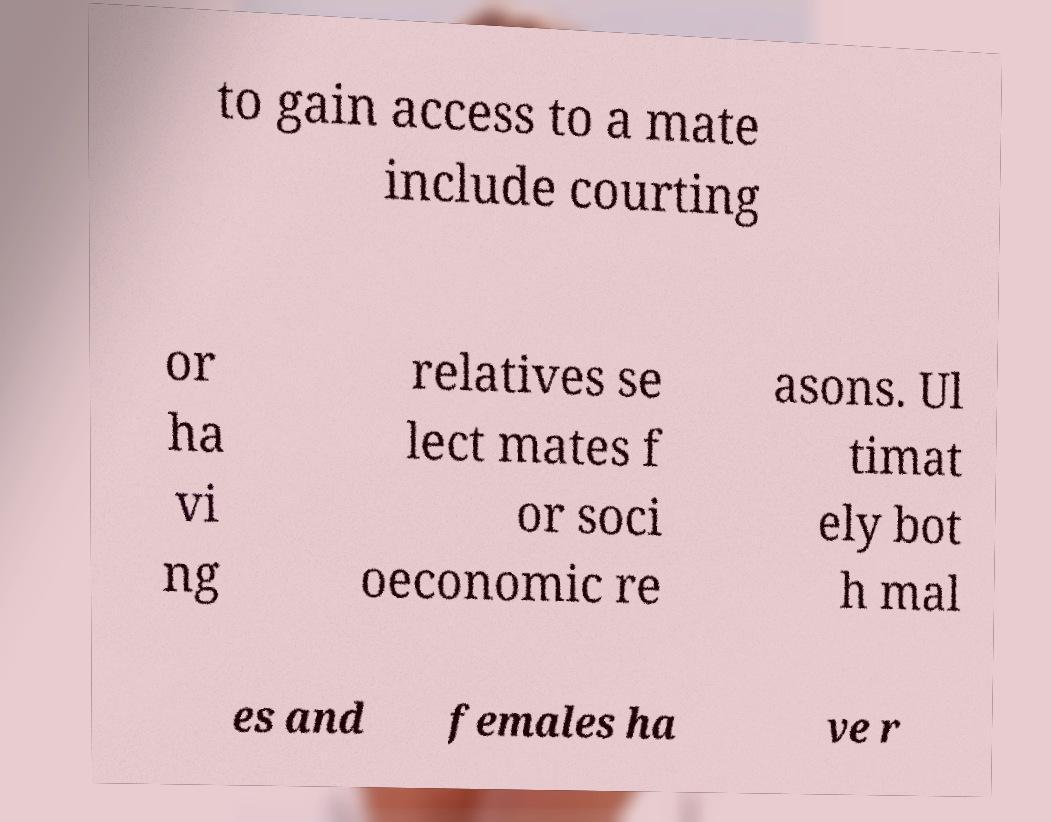I need the written content from this picture converted into text. Can you do that? to gain access to a mate include courting or ha vi ng relatives se lect mates f or soci oeconomic re asons. Ul timat ely bot h mal es and females ha ve r 